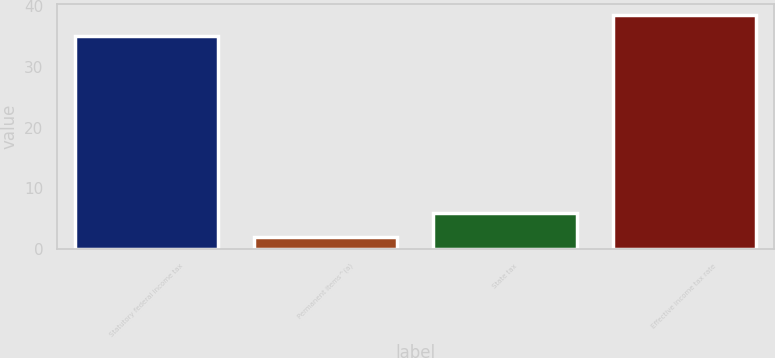<chart> <loc_0><loc_0><loc_500><loc_500><bar_chart><fcel>Statutory federal income tax<fcel>Permanent items^(a)<fcel>State tax<fcel>Effective income tax rate<nl><fcel>35<fcel>2<fcel>6<fcel>38.4<nl></chart> 